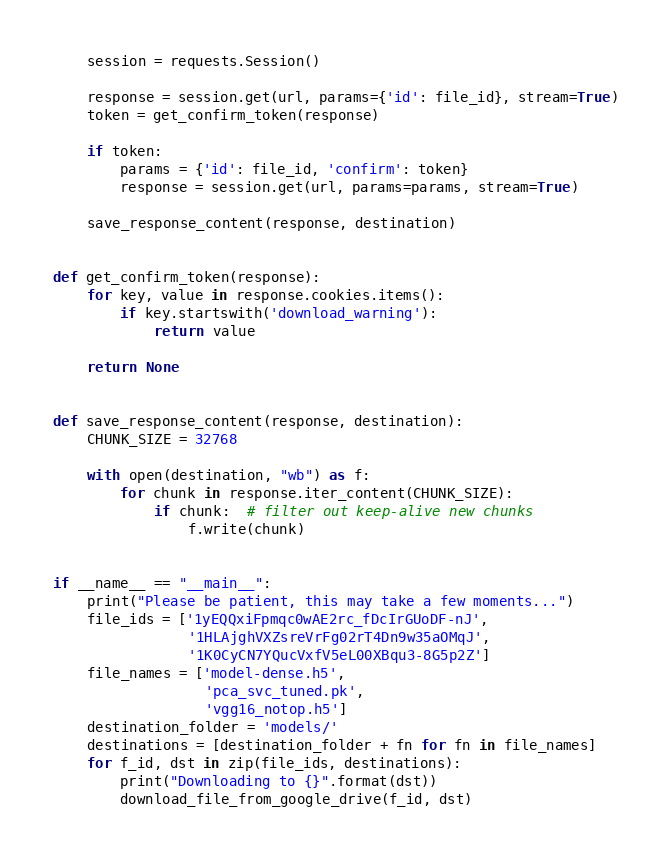Convert code to text. <code><loc_0><loc_0><loc_500><loc_500><_Python_>    session = requests.Session()

    response = session.get(url, params={'id': file_id}, stream=True)
    token = get_confirm_token(response)

    if token:
        params = {'id': file_id, 'confirm': token}
        response = session.get(url, params=params, stream=True)

    save_response_content(response, destination)


def get_confirm_token(response):
    for key, value in response.cookies.items():
        if key.startswith('download_warning'):
            return value

    return None


def save_response_content(response, destination):
    CHUNK_SIZE = 32768

    with open(destination, "wb") as f:
        for chunk in response.iter_content(CHUNK_SIZE):
            if chunk:  # filter out keep-alive new chunks
                f.write(chunk)


if __name__ == "__main__":
    print("Please be patient, this may take a few moments...")
    file_ids = ['1yEQQxiFpmqc0wAE2rc_fDcIrGUoDF-nJ',
                '1HLAjghVXZsreVrFg02rT4Dn9w35aOMqJ',
                '1K0CyCN7YQucVxfV5eL00XBqu3-8G5p2Z']
    file_names = ['model-dense.h5',
                  'pca_svc_tuned.pk',
                  'vgg16_notop.h5']
    destination_folder = 'models/'
    destinations = [destination_folder + fn for fn in file_names]
    for f_id, dst in zip(file_ids, destinations):
        print("Downloading to {}".format(dst))
        download_file_from_google_drive(f_id, dst)
</code> 